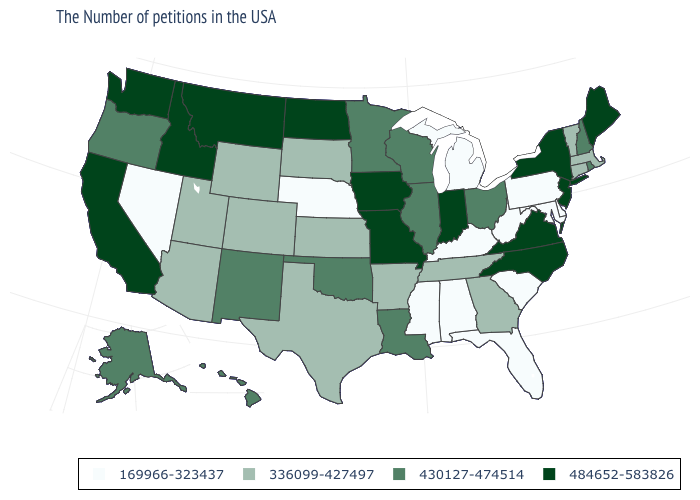Which states have the lowest value in the USA?
Quick response, please. Delaware, Maryland, Pennsylvania, South Carolina, West Virginia, Florida, Michigan, Kentucky, Alabama, Mississippi, Nebraska, Nevada. What is the value of Delaware?
Write a very short answer. 169966-323437. Among the states that border Texas , which have the lowest value?
Give a very brief answer. Arkansas. What is the value of Wisconsin?
Give a very brief answer. 430127-474514. Does Rhode Island have the highest value in the USA?
Be succinct. No. Among the states that border Georgia , does North Carolina have the lowest value?
Be succinct. No. What is the value of Washington?
Write a very short answer. 484652-583826. How many symbols are there in the legend?
Short answer required. 4. Name the states that have a value in the range 169966-323437?
Concise answer only. Delaware, Maryland, Pennsylvania, South Carolina, West Virginia, Florida, Michigan, Kentucky, Alabama, Mississippi, Nebraska, Nevada. Among the states that border New York , does Connecticut have the lowest value?
Short answer required. No. What is the value of Washington?
Give a very brief answer. 484652-583826. Which states hav the highest value in the MidWest?
Quick response, please. Indiana, Missouri, Iowa, North Dakota. What is the value of Florida?
Quick response, please. 169966-323437. What is the highest value in the South ?
Concise answer only. 484652-583826. Name the states that have a value in the range 484652-583826?
Be succinct. Maine, New York, New Jersey, Virginia, North Carolina, Indiana, Missouri, Iowa, North Dakota, Montana, Idaho, California, Washington. 